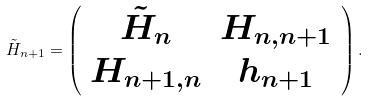<formula> <loc_0><loc_0><loc_500><loc_500>\tilde { H } _ { n + 1 } = \left ( \begin{array} { c c } \tilde { H } _ { n } & H _ { n , n + 1 } \\ H _ { n + 1 , n } & h _ { n + 1 } \end{array} \right ) .</formula> 